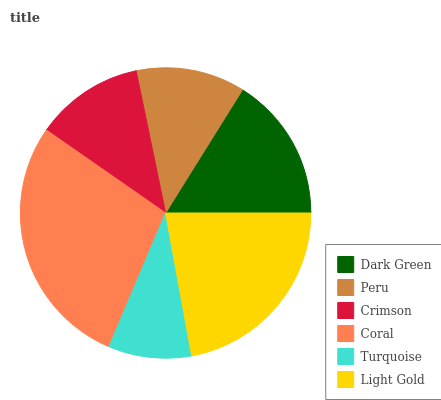Is Turquoise the minimum?
Answer yes or no. Yes. Is Coral the maximum?
Answer yes or no. Yes. Is Peru the minimum?
Answer yes or no. No. Is Peru the maximum?
Answer yes or no. No. Is Dark Green greater than Peru?
Answer yes or no. Yes. Is Peru less than Dark Green?
Answer yes or no. Yes. Is Peru greater than Dark Green?
Answer yes or no. No. Is Dark Green less than Peru?
Answer yes or no. No. Is Dark Green the high median?
Answer yes or no. Yes. Is Peru the low median?
Answer yes or no. Yes. Is Peru the high median?
Answer yes or no. No. Is Turquoise the low median?
Answer yes or no. No. 